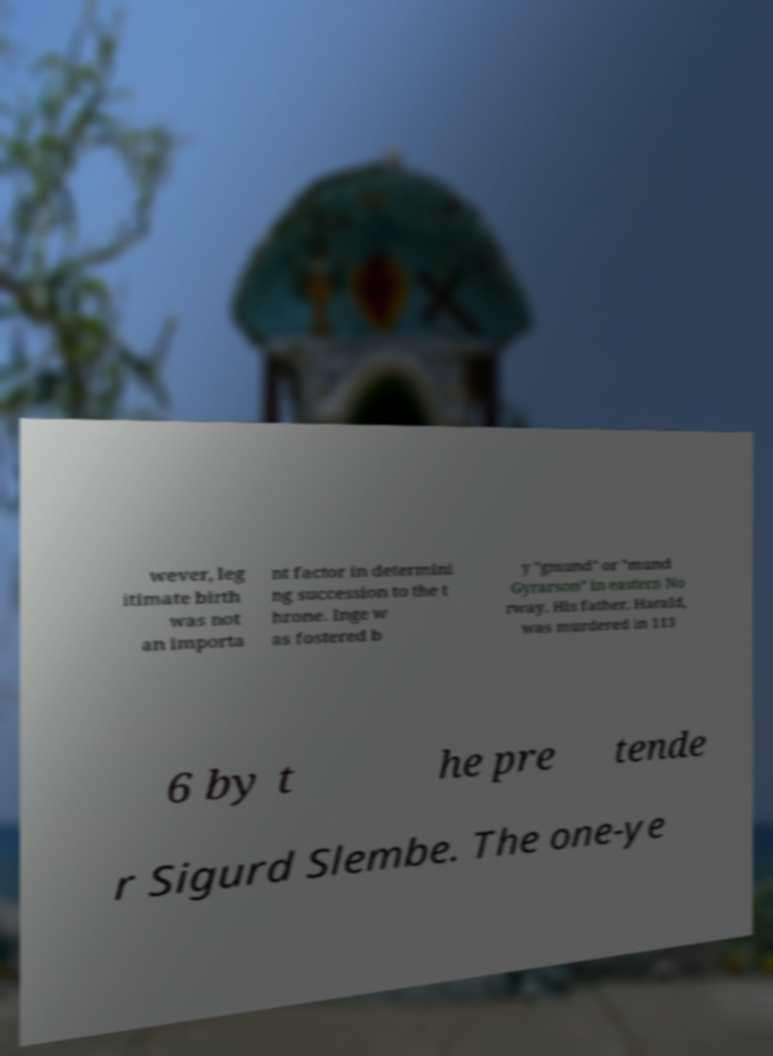For documentation purposes, I need the text within this image transcribed. Could you provide that? wever, leg itimate birth was not an importa nt factor in determini ng succession to the t hrone. Inge w as fostered b y "gmund" or "mund Gyrarson" in eastern No rway. His father, Harald, was murdered in 113 6 by t he pre tende r Sigurd Slembe. The one-ye 